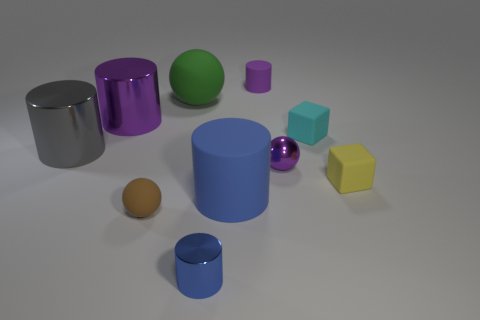Subtract 1 cylinders. How many cylinders are left? 4 Subtract all cyan cylinders. Subtract all blue cubes. How many cylinders are left? 5 Subtract all spheres. How many objects are left? 7 Add 7 small metal objects. How many small metal objects are left? 9 Add 3 tiny rubber spheres. How many tiny rubber spheres exist? 4 Subtract 1 gray cylinders. How many objects are left? 9 Subtract all purple things. Subtract all tiny yellow cubes. How many objects are left? 6 